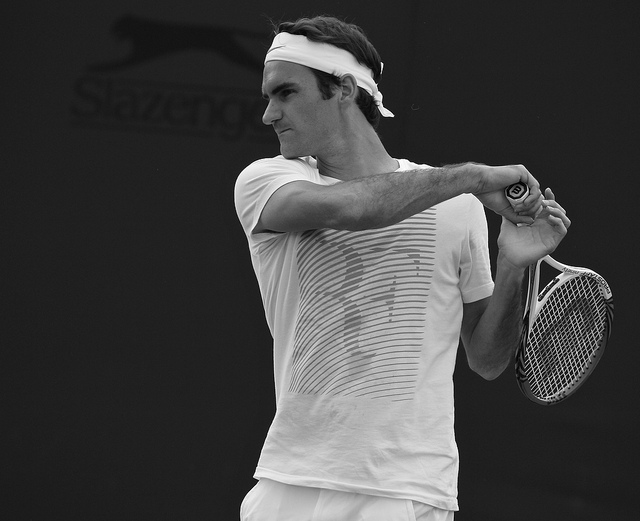<image>What color is the symbol on the man's head tie? I am not sure. The color of the symbol on the man's head tie can be either black, white or gray. What color is the symbol on the man's head tie? I don't know what color is the symbol on the man's head tie. It can be seen black, white, gray or nike. 